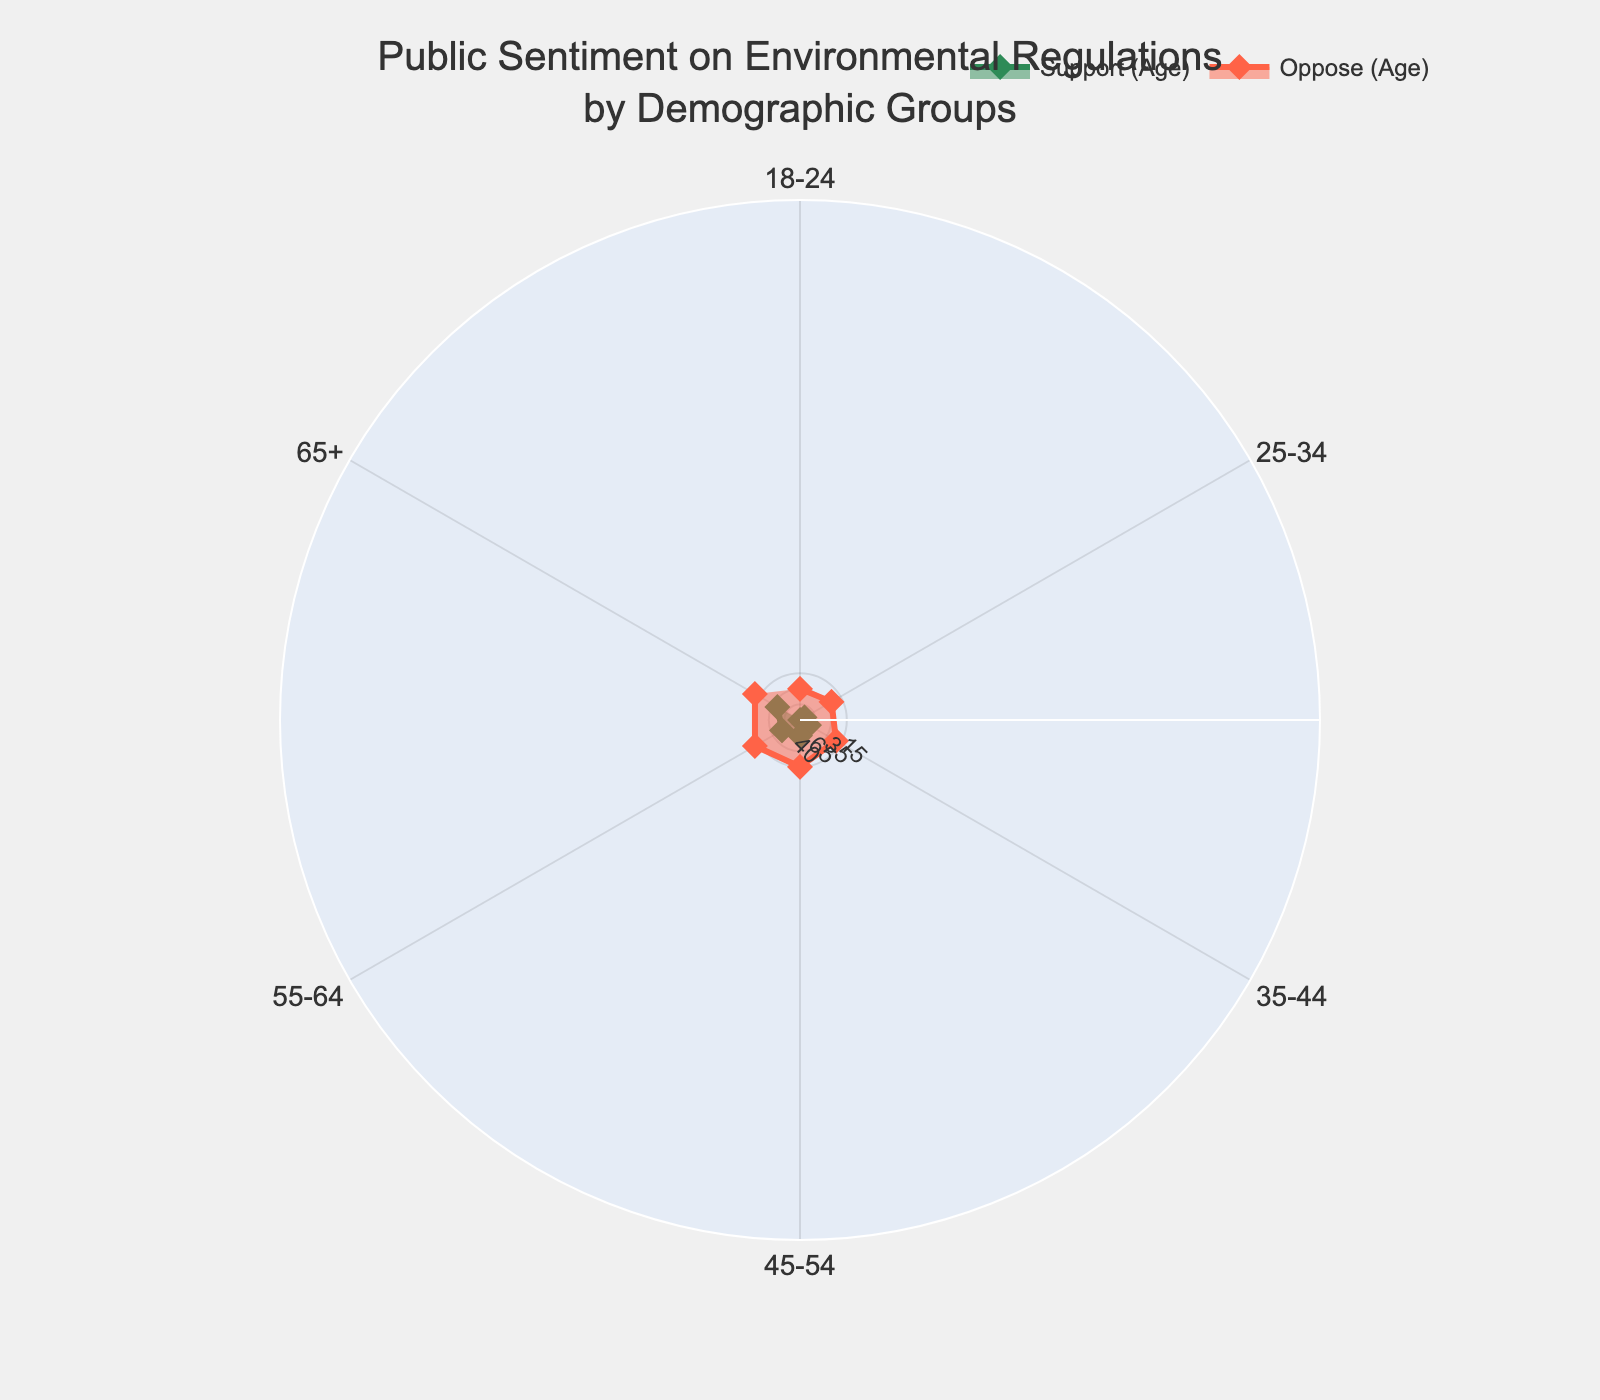What is the title of the figure? The title is prominently placed at the top of the figure and describes the data being visualized.
Answer: Public Sentiment on Environmental Regulations by Demographic Groups Which age group shows the highest support for environmental regulations? Look at the trace for 'Support (Age)' and identify the age group with the highest value.
Answer: 65+ What is the difference in support for environmental regulations between the 18-24 and 55-64 age groups? Find the support values for both age groups and subtract the former from the latter: 70 (for 55-64) - 40 (for 18-24).
Answer: 30 Which demographic group has a more uniform sentiment across different educational levels regarding their opposition to environmental regulations? Compare the 'Oppose (Education)' trace values for uniformity across educational levels.
Answer: Education By how much does support for environmental regulations among those with a Doctorate degree exceed that of those with an Associate Degree? Subtract the support value of those with an Associate Degree (55) from that of those with a Doctorate (80).
Answer: 25 Calculate the average opposition to environmental regulations across all age groups. Sum the 'Oppose Regulation' values for all age groups and divide by the number of age groups: (35+25+20+15+10+10)/6.
Answer: 19.17 What color is used to represent support for environmental regulations in the age group traces? Identify the line color of the 'Support (Age)' trace.
Answer: Green In terms of 'Neutral' stance, which demographic group tends to have a comparatively higher number, age groups or education levels? Compare the 'Neutral' values between age groups and education levels and identify which is generally higher.
Answer: Age groups Which group, by age or by education, shows a maximum opposition rate of 30% or higher? Identify the maximum opposition rates for both age groups and education levels; compare to see if any exceed 30%.
Answer: Neither 